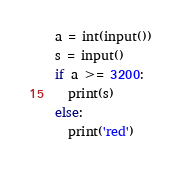Convert code to text. <code><loc_0><loc_0><loc_500><loc_500><_Python_>a = int(input())
s = input()
if a >= 3200:
  print(s)
else:
  print('red')</code> 